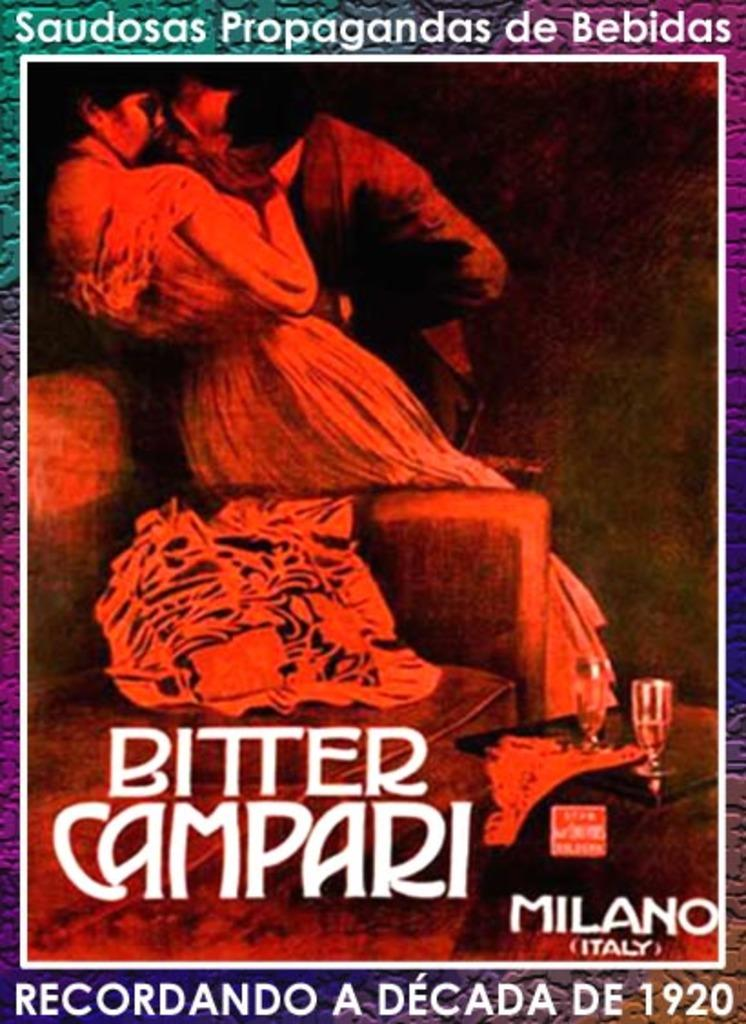<image>
Give a short and clear explanation of the subsequent image. a poster bitter campari by milano italy bebidas 